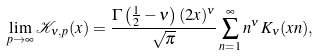Convert formula to latex. <formula><loc_0><loc_0><loc_500><loc_500>\lim _ { p \rightarrow \infty } \mathcal { K } _ { \nu , p } ( x ) = \frac { \Gamma \left ( \frac { 1 } { 2 } - \nu \right ) ( 2 x ) ^ { \nu } } { \sqrt { \pi } } \sum _ { n = 1 } ^ { \infty } n ^ { \nu } \, K _ { \nu } ( x n ) ,</formula> 